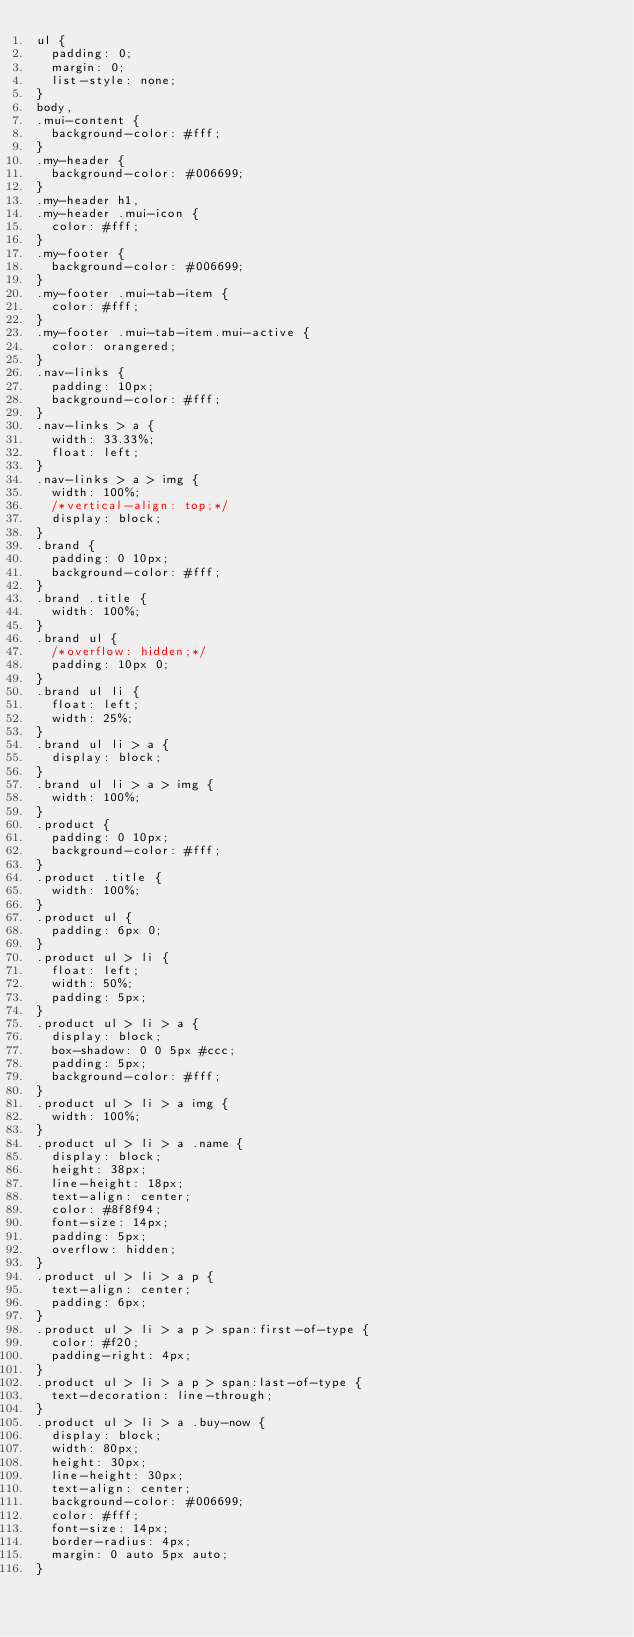<code> <loc_0><loc_0><loc_500><loc_500><_CSS_>ul {
  padding: 0;
  margin: 0;
  list-style: none;
}
body,
.mui-content {
  background-color: #fff;
}
.my-header {
  background-color: #006699;
}
.my-header h1,
.my-header .mui-icon {
  color: #fff;
}
.my-footer {
  background-color: #006699;
}
.my-footer .mui-tab-item {
  color: #fff;
}
.my-footer .mui-tab-item.mui-active {
  color: orangered;
}
.nav-links {
  padding: 10px;
  background-color: #fff;
}
.nav-links > a {
  width: 33.33%;
  float: left;
}
.nav-links > a > img {
  width: 100%;
  /*vertical-align: top;*/
  display: block;
}
.brand {
  padding: 0 10px;
  background-color: #fff;
}
.brand .title {
  width: 100%;
}
.brand ul {
  /*overflow: hidden;*/
  padding: 10px 0;
}
.brand ul li {
  float: left;
  width: 25%;
}
.brand ul li > a {
  display: block;
}
.brand ul li > a > img {
  width: 100%;
}
.product {
  padding: 0 10px;
  background-color: #fff;
}
.product .title {
  width: 100%;
}
.product ul {
  padding: 6px 0;
}
.product ul > li {
  float: left;
  width: 50%;
  padding: 5px;
}
.product ul > li > a {
  display: block;
  box-shadow: 0 0 5px #ccc;
  padding: 5px;
  background-color: #fff;
}
.product ul > li > a img {
  width: 100%;
}
.product ul > li > a .name {
  display: block;
  height: 38px;
  line-height: 18px;
  text-align: center;
  color: #8f8f94;
  font-size: 14px;
  padding: 5px;
  overflow: hidden;
}
.product ul > li > a p {
  text-align: center;
  padding: 6px;
}
.product ul > li > a p > span:first-of-type {
  color: #f20;
  padding-right: 4px;
}
.product ul > li > a p > span:last-of-type {
  text-decoration: line-through;
}
.product ul > li > a .buy-now {
  display: block;
  width: 80px;
  height: 30px;
  line-height: 30px;
  text-align: center;
  background-color: #006699;
  color: #fff;
  font-size: 14px;
  border-radius: 4px;
  margin: 0 auto 5px auto;
}
</code> 